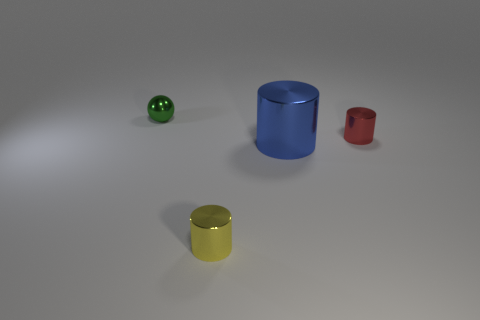There is a yellow thing that is the same size as the red metal cylinder; what is its shape?
Make the answer very short. Cylinder. Are there an equal number of things that are on the left side of the green metal object and large shiny cubes?
Keep it short and to the point. Yes. There is a small green object that is the same material as the large object; what is its shape?
Provide a short and direct response. Sphere. How many big blue cylinders are in front of the small cylinder right of the tiny thing in front of the red cylinder?
Offer a terse response. 1. What number of green things are metallic things or metal spheres?
Your answer should be very brief. 1. There is a sphere; is it the same size as the cylinder to the right of the blue metal object?
Offer a terse response. Yes. There is a tiny yellow thing that is the same shape as the red thing; what is it made of?
Make the answer very short. Metal. How many other things are the same size as the metal ball?
Provide a short and direct response. 2. There is a thing behind the small cylinder that is behind the small yellow thing that is left of the tiny red shiny object; what shape is it?
Provide a short and direct response. Sphere. What shape is the metal thing that is in front of the green metallic thing and behind the large object?
Offer a very short reply. Cylinder. 